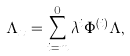Convert formula to latex. <formula><loc_0><loc_0><loc_500><loc_500>\Lambda _ { x } = \sum _ { i = m } ^ { 0 } \lambda ^ { i } \Phi ^ { ( i ) } \Lambda ,</formula> 